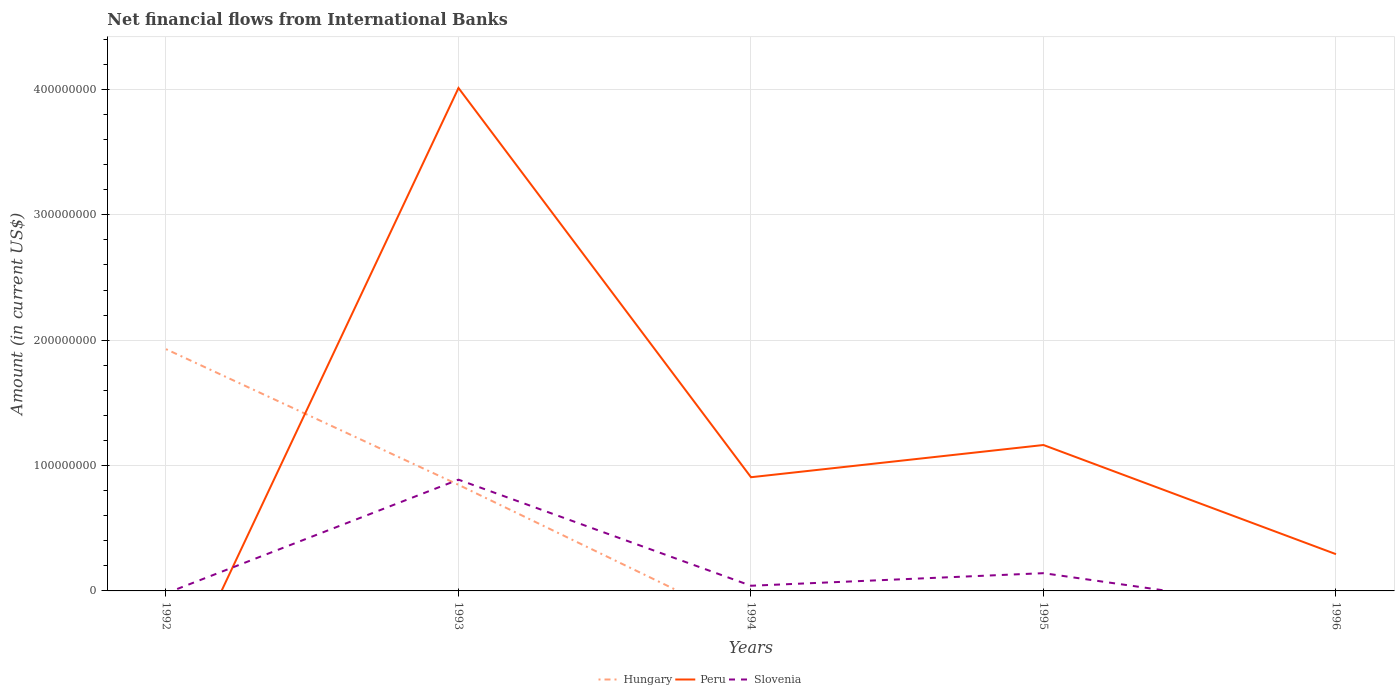Is the number of lines equal to the number of legend labels?
Offer a very short reply. No. Across all years, what is the maximum net financial aid flows in Peru?
Give a very brief answer. 0. What is the total net financial aid flows in Peru in the graph?
Your answer should be compact. 2.85e+08. What is the difference between the highest and the second highest net financial aid flows in Peru?
Give a very brief answer. 4.01e+08. How many years are there in the graph?
Ensure brevity in your answer.  5. Are the values on the major ticks of Y-axis written in scientific E-notation?
Give a very brief answer. No. Where does the legend appear in the graph?
Make the answer very short. Bottom center. What is the title of the graph?
Provide a short and direct response. Net financial flows from International Banks. Does "United States" appear as one of the legend labels in the graph?
Make the answer very short. No. What is the label or title of the X-axis?
Provide a short and direct response. Years. What is the Amount (in current US$) in Hungary in 1992?
Your response must be concise. 1.93e+08. What is the Amount (in current US$) in Hungary in 1993?
Your response must be concise. 8.46e+07. What is the Amount (in current US$) in Peru in 1993?
Provide a short and direct response. 4.01e+08. What is the Amount (in current US$) in Slovenia in 1993?
Give a very brief answer. 8.87e+07. What is the Amount (in current US$) in Hungary in 1994?
Make the answer very short. 0. What is the Amount (in current US$) in Peru in 1994?
Offer a very short reply. 9.07e+07. What is the Amount (in current US$) in Slovenia in 1994?
Make the answer very short. 4.12e+06. What is the Amount (in current US$) of Peru in 1995?
Keep it short and to the point. 1.16e+08. What is the Amount (in current US$) in Slovenia in 1995?
Ensure brevity in your answer.  1.42e+07. What is the Amount (in current US$) of Peru in 1996?
Provide a short and direct response. 2.93e+07. What is the Amount (in current US$) of Slovenia in 1996?
Ensure brevity in your answer.  0. Across all years, what is the maximum Amount (in current US$) of Hungary?
Offer a terse response. 1.93e+08. Across all years, what is the maximum Amount (in current US$) of Peru?
Your answer should be very brief. 4.01e+08. Across all years, what is the maximum Amount (in current US$) in Slovenia?
Make the answer very short. 8.87e+07. Across all years, what is the minimum Amount (in current US$) of Hungary?
Your answer should be compact. 0. Across all years, what is the minimum Amount (in current US$) of Slovenia?
Your answer should be very brief. 0. What is the total Amount (in current US$) in Hungary in the graph?
Your answer should be compact. 2.77e+08. What is the total Amount (in current US$) of Peru in the graph?
Offer a very short reply. 6.37e+08. What is the total Amount (in current US$) of Slovenia in the graph?
Provide a succinct answer. 1.07e+08. What is the difference between the Amount (in current US$) in Hungary in 1992 and that in 1993?
Make the answer very short. 1.08e+08. What is the difference between the Amount (in current US$) of Peru in 1993 and that in 1994?
Your answer should be compact. 3.10e+08. What is the difference between the Amount (in current US$) in Slovenia in 1993 and that in 1994?
Your response must be concise. 8.46e+07. What is the difference between the Amount (in current US$) of Peru in 1993 and that in 1995?
Give a very brief answer. 2.85e+08. What is the difference between the Amount (in current US$) in Slovenia in 1993 and that in 1995?
Give a very brief answer. 7.46e+07. What is the difference between the Amount (in current US$) of Peru in 1993 and that in 1996?
Ensure brevity in your answer.  3.72e+08. What is the difference between the Amount (in current US$) in Peru in 1994 and that in 1995?
Offer a terse response. -2.57e+07. What is the difference between the Amount (in current US$) of Slovenia in 1994 and that in 1995?
Provide a short and direct response. -1.00e+07. What is the difference between the Amount (in current US$) in Peru in 1994 and that in 1996?
Offer a terse response. 6.14e+07. What is the difference between the Amount (in current US$) of Peru in 1995 and that in 1996?
Make the answer very short. 8.71e+07. What is the difference between the Amount (in current US$) of Hungary in 1992 and the Amount (in current US$) of Peru in 1993?
Offer a very short reply. -2.08e+08. What is the difference between the Amount (in current US$) in Hungary in 1992 and the Amount (in current US$) in Slovenia in 1993?
Keep it short and to the point. 1.04e+08. What is the difference between the Amount (in current US$) in Hungary in 1992 and the Amount (in current US$) in Peru in 1994?
Ensure brevity in your answer.  1.02e+08. What is the difference between the Amount (in current US$) in Hungary in 1992 and the Amount (in current US$) in Slovenia in 1994?
Ensure brevity in your answer.  1.89e+08. What is the difference between the Amount (in current US$) of Hungary in 1992 and the Amount (in current US$) of Peru in 1995?
Give a very brief answer. 7.65e+07. What is the difference between the Amount (in current US$) of Hungary in 1992 and the Amount (in current US$) of Slovenia in 1995?
Provide a short and direct response. 1.79e+08. What is the difference between the Amount (in current US$) in Hungary in 1992 and the Amount (in current US$) in Peru in 1996?
Give a very brief answer. 1.64e+08. What is the difference between the Amount (in current US$) in Hungary in 1993 and the Amount (in current US$) in Peru in 1994?
Provide a short and direct response. -6.04e+06. What is the difference between the Amount (in current US$) of Hungary in 1993 and the Amount (in current US$) of Slovenia in 1994?
Your answer should be very brief. 8.05e+07. What is the difference between the Amount (in current US$) of Peru in 1993 and the Amount (in current US$) of Slovenia in 1994?
Offer a very short reply. 3.97e+08. What is the difference between the Amount (in current US$) in Hungary in 1993 and the Amount (in current US$) in Peru in 1995?
Offer a very short reply. -3.17e+07. What is the difference between the Amount (in current US$) in Hungary in 1993 and the Amount (in current US$) in Slovenia in 1995?
Your response must be concise. 7.05e+07. What is the difference between the Amount (in current US$) of Peru in 1993 and the Amount (in current US$) of Slovenia in 1995?
Offer a very short reply. 3.87e+08. What is the difference between the Amount (in current US$) of Hungary in 1993 and the Amount (in current US$) of Peru in 1996?
Offer a terse response. 5.53e+07. What is the difference between the Amount (in current US$) of Peru in 1994 and the Amount (in current US$) of Slovenia in 1995?
Offer a terse response. 7.65e+07. What is the average Amount (in current US$) in Hungary per year?
Offer a very short reply. 5.55e+07. What is the average Amount (in current US$) in Peru per year?
Your answer should be compact. 1.27e+08. What is the average Amount (in current US$) in Slovenia per year?
Provide a short and direct response. 2.14e+07. In the year 1993, what is the difference between the Amount (in current US$) of Hungary and Amount (in current US$) of Peru?
Your answer should be very brief. -3.16e+08. In the year 1993, what is the difference between the Amount (in current US$) in Hungary and Amount (in current US$) in Slovenia?
Offer a very short reply. -4.10e+06. In the year 1993, what is the difference between the Amount (in current US$) in Peru and Amount (in current US$) in Slovenia?
Offer a terse response. 3.12e+08. In the year 1994, what is the difference between the Amount (in current US$) in Peru and Amount (in current US$) in Slovenia?
Make the answer very short. 8.66e+07. In the year 1995, what is the difference between the Amount (in current US$) in Peru and Amount (in current US$) in Slovenia?
Your answer should be very brief. 1.02e+08. What is the ratio of the Amount (in current US$) of Hungary in 1992 to that in 1993?
Keep it short and to the point. 2.28. What is the ratio of the Amount (in current US$) of Peru in 1993 to that in 1994?
Make the answer very short. 4.42. What is the ratio of the Amount (in current US$) in Slovenia in 1993 to that in 1994?
Your answer should be very brief. 21.52. What is the ratio of the Amount (in current US$) in Peru in 1993 to that in 1995?
Your response must be concise. 3.45. What is the ratio of the Amount (in current US$) of Slovenia in 1993 to that in 1995?
Provide a succinct answer. 6.27. What is the ratio of the Amount (in current US$) in Peru in 1993 to that in 1996?
Provide a short and direct response. 13.69. What is the ratio of the Amount (in current US$) of Peru in 1994 to that in 1995?
Make the answer very short. 0.78. What is the ratio of the Amount (in current US$) in Slovenia in 1994 to that in 1995?
Provide a short and direct response. 0.29. What is the ratio of the Amount (in current US$) of Peru in 1994 to that in 1996?
Your answer should be compact. 3.09. What is the ratio of the Amount (in current US$) in Peru in 1995 to that in 1996?
Your response must be concise. 3.97. What is the difference between the highest and the second highest Amount (in current US$) in Peru?
Provide a short and direct response. 2.85e+08. What is the difference between the highest and the second highest Amount (in current US$) of Slovenia?
Give a very brief answer. 7.46e+07. What is the difference between the highest and the lowest Amount (in current US$) in Hungary?
Provide a succinct answer. 1.93e+08. What is the difference between the highest and the lowest Amount (in current US$) in Peru?
Your response must be concise. 4.01e+08. What is the difference between the highest and the lowest Amount (in current US$) in Slovenia?
Keep it short and to the point. 8.87e+07. 